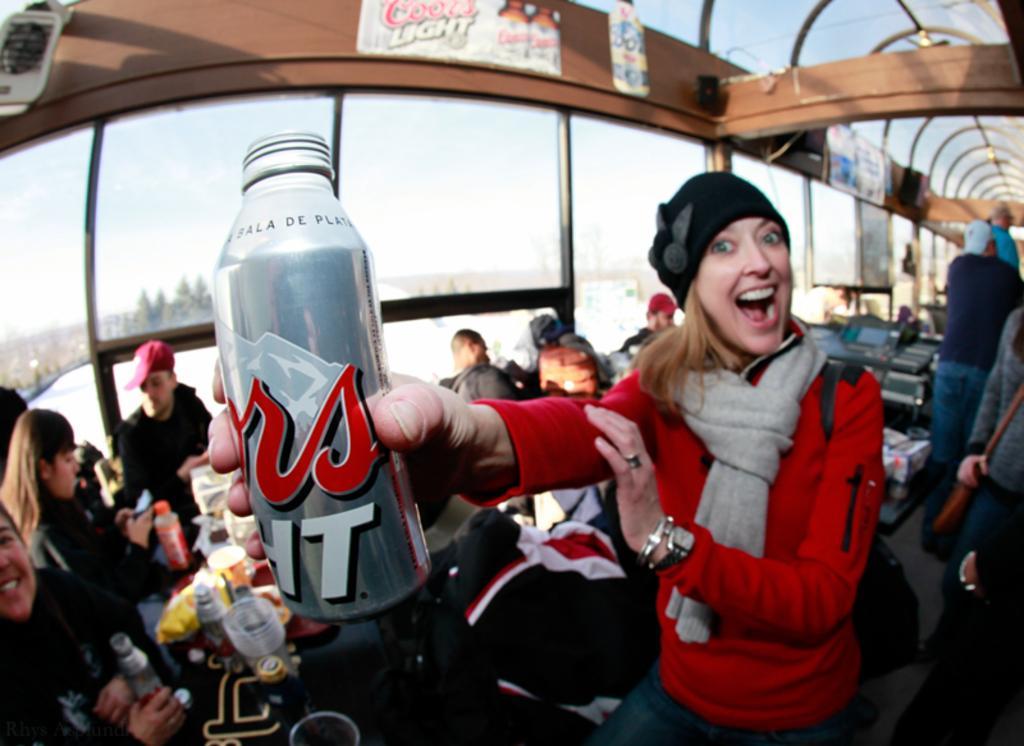Can you describe this image briefly? A woman is posing to camera holding a container in her hand. There are some people sitting at a tables behind her. 